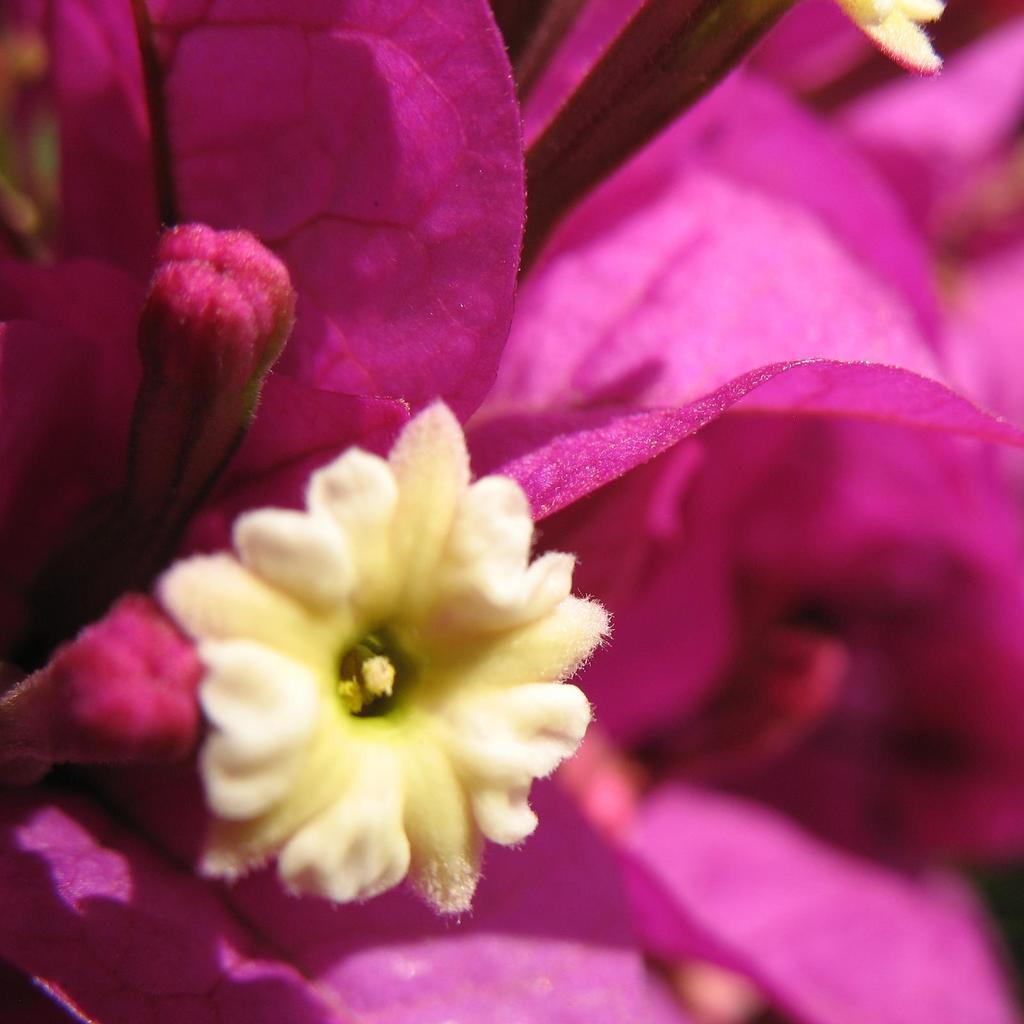Describe this image in one or two sentences. In this picture I can see there is a flower it is in pink and cream color and also there is a bud. 